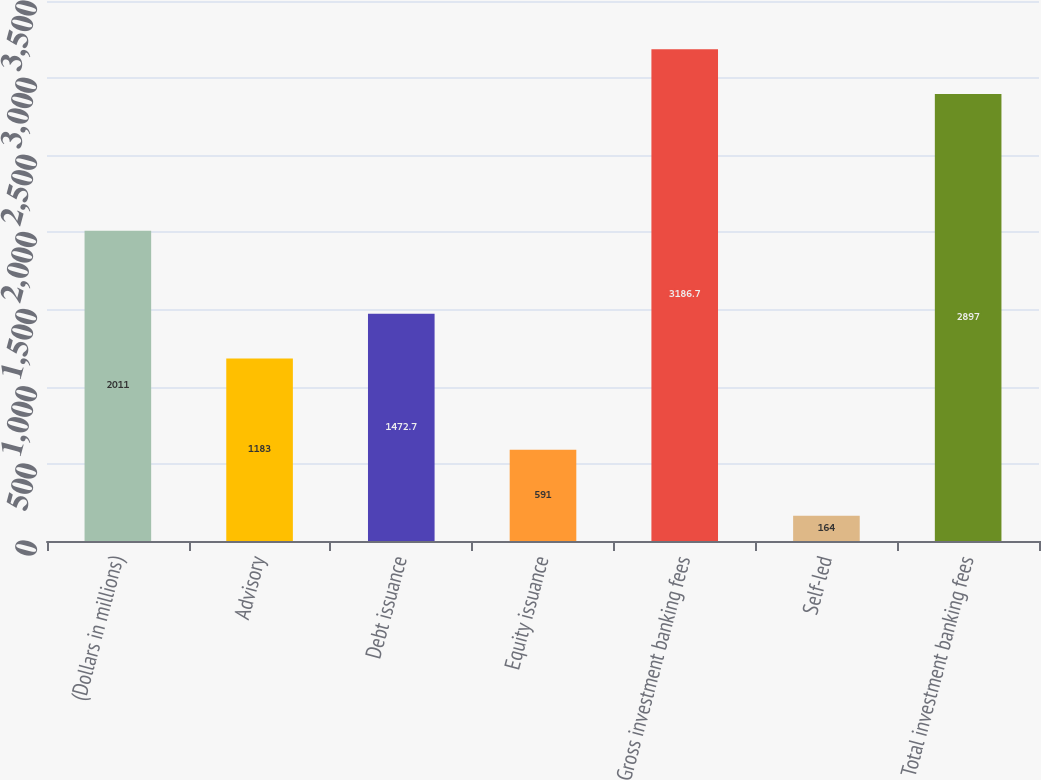<chart> <loc_0><loc_0><loc_500><loc_500><bar_chart><fcel>(Dollars in millions)<fcel>Advisory<fcel>Debt issuance<fcel>Equity issuance<fcel>Gross investment banking fees<fcel>Self-led<fcel>Total investment banking fees<nl><fcel>2011<fcel>1183<fcel>1472.7<fcel>591<fcel>3186.7<fcel>164<fcel>2897<nl></chart> 